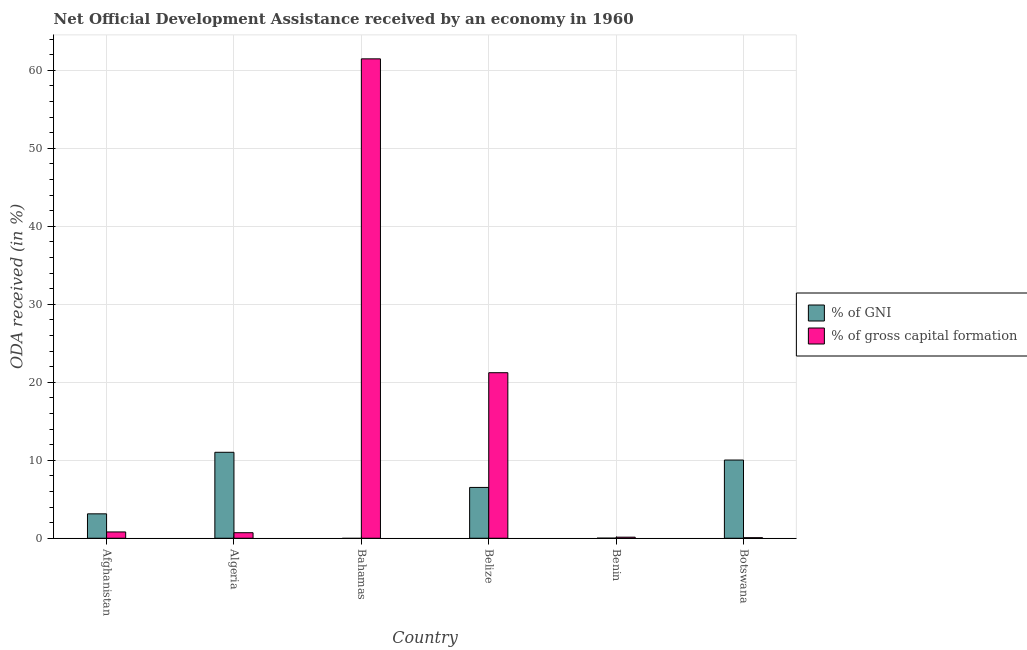How many different coloured bars are there?
Your answer should be compact. 2. Are the number of bars per tick equal to the number of legend labels?
Offer a very short reply. No. Are the number of bars on each tick of the X-axis equal?
Keep it short and to the point. No. How many bars are there on the 1st tick from the right?
Your answer should be very brief. 2. What is the label of the 6th group of bars from the left?
Provide a succinct answer. Botswana. What is the oda received as percentage of gni in Bahamas?
Your answer should be compact. 0. Across all countries, what is the maximum oda received as percentage of gni?
Give a very brief answer. 11.02. Across all countries, what is the minimum oda received as percentage of gross capital formation?
Provide a short and direct response. 0.07. In which country was the oda received as percentage of gni maximum?
Offer a terse response. Algeria. What is the total oda received as percentage of gross capital formation in the graph?
Keep it short and to the point. 84.42. What is the difference between the oda received as percentage of gross capital formation in Belize and that in Botswana?
Provide a succinct answer. 21.16. What is the difference between the oda received as percentage of gni in Bahamas and the oda received as percentage of gross capital formation in Belize?
Your response must be concise. -21.23. What is the average oda received as percentage of gni per country?
Give a very brief answer. 5.12. What is the difference between the oda received as percentage of gross capital formation and oda received as percentage of gni in Afghanistan?
Your answer should be compact. -2.32. In how many countries, is the oda received as percentage of gross capital formation greater than 36 %?
Ensure brevity in your answer.  1. What is the ratio of the oda received as percentage of gross capital formation in Algeria to that in Bahamas?
Make the answer very short. 0.01. What is the difference between the highest and the second highest oda received as percentage of gross capital formation?
Provide a succinct answer. 40.24. What is the difference between the highest and the lowest oda received as percentage of gross capital formation?
Provide a short and direct response. 61.4. In how many countries, is the oda received as percentage of gni greater than the average oda received as percentage of gni taken over all countries?
Provide a short and direct response. 3. Is the sum of the oda received as percentage of gross capital formation in Algeria and Bahamas greater than the maximum oda received as percentage of gni across all countries?
Keep it short and to the point. Yes. How many bars are there?
Provide a succinct answer. 11. Are all the bars in the graph horizontal?
Ensure brevity in your answer.  No. How many countries are there in the graph?
Give a very brief answer. 6. Does the graph contain grids?
Give a very brief answer. Yes. How are the legend labels stacked?
Provide a succinct answer. Vertical. What is the title of the graph?
Provide a succinct answer. Net Official Development Assistance received by an economy in 1960. What is the label or title of the Y-axis?
Offer a terse response. ODA received (in %). What is the ODA received (in %) in % of GNI in Afghanistan?
Your response must be concise. 3.13. What is the ODA received (in %) in % of gross capital formation in Afghanistan?
Keep it short and to the point. 0.81. What is the ODA received (in %) in % of GNI in Algeria?
Provide a succinct answer. 11.02. What is the ODA received (in %) of % of gross capital formation in Algeria?
Keep it short and to the point. 0.71. What is the ODA received (in %) of % of gross capital formation in Bahamas?
Give a very brief answer. 61.47. What is the ODA received (in %) in % of GNI in Belize?
Your response must be concise. 6.52. What is the ODA received (in %) in % of gross capital formation in Belize?
Offer a terse response. 21.23. What is the ODA received (in %) of % of GNI in Benin?
Your answer should be very brief. 0.01. What is the ODA received (in %) of % of gross capital formation in Benin?
Make the answer very short. 0.14. What is the ODA received (in %) in % of GNI in Botswana?
Ensure brevity in your answer.  10.03. What is the ODA received (in %) of % of gross capital formation in Botswana?
Provide a short and direct response. 0.07. Across all countries, what is the maximum ODA received (in %) in % of GNI?
Make the answer very short. 11.02. Across all countries, what is the maximum ODA received (in %) in % of gross capital formation?
Ensure brevity in your answer.  61.47. Across all countries, what is the minimum ODA received (in %) of % of gross capital formation?
Ensure brevity in your answer.  0.07. What is the total ODA received (in %) in % of GNI in the graph?
Your answer should be very brief. 30.7. What is the total ODA received (in %) of % of gross capital formation in the graph?
Give a very brief answer. 84.42. What is the difference between the ODA received (in %) of % of GNI in Afghanistan and that in Algeria?
Keep it short and to the point. -7.89. What is the difference between the ODA received (in %) of % of gross capital formation in Afghanistan and that in Algeria?
Offer a terse response. 0.1. What is the difference between the ODA received (in %) in % of gross capital formation in Afghanistan and that in Bahamas?
Keep it short and to the point. -60.66. What is the difference between the ODA received (in %) in % of GNI in Afghanistan and that in Belize?
Make the answer very short. -3.39. What is the difference between the ODA received (in %) of % of gross capital formation in Afghanistan and that in Belize?
Offer a very short reply. -20.42. What is the difference between the ODA received (in %) in % of GNI in Afghanistan and that in Benin?
Your response must be concise. 3.12. What is the difference between the ODA received (in %) in % of gross capital formation in Afghanistan and that in Benin?
Keep it short and to the point. 0.67. What is the difference between the ODA received (in %) in % of GNI in Afghanistan and that in Botswana?
Your response must be concise. -6.9. What is the difference between the ODA received (in %) of % of gross capital formation in Afghanistan and that in Botswana?
Make the answer very short. 0.74. What is the difference between the ODA received (in %) of % of gross capital formation in Algeria and that in Bahamas?
Your answer should be compact. -60.76. What is the difference between the ODA received (in %) of % of GNI in Algeria and that in Belize?
Your answer should be compact. 4.51. What is the difference between the ODA received (in %) in % of gross capital formation in Algeria and that in Belize?
Your answer should be very brief. -20.52. What is the difference between the ODA received (in %) of % of GNI in Algeria and that in Benin?
Keep it short and to the point. 11.01. What is the difference between the ODA received (in %) in % of gross capital formation in Algeria and that in Benin?
Your answer should be compact. 0.57. What is the difference between the ODA received (in %) in % of GNI in Algeria and that in Botswana?
Your answer should be compact. 0.99. What is the difference between the ODA received (in %) in % of gross capital formation in Algeria and that in Botswana?
Offer a very short reply. 0.64. What is the difference between the ODA received (in %) in % of gross capital formation in Bahamas and that in Belize?
Your answer should be very brief. 40.24. What is the difference between the ODA received (in %) in % of gross capital formation in Bahamas and that in Benin?
Make the answer very short. 61.33. What is the difference between the ODA received (in %) in % of gross capital formation in Bahamas and that in Botswana?
Make the answer very short. 61.4. What is the difference between the ODA received (in %) of % of GNI in Belize and that in Benin?
Keep it short and to the point. 6.51. What is the difference between the ODA received (in %) of % of gross capital formation in Belize and that in Benin?
Offer a very short reply. 21.09. What is the difference between the ODA received (in %) in % of GNI in Belize and that in Botswana?
Provide a succinct answer. -3.51. What is the difference between the ODA received (in %) of % of gross capital formation in Belize and that in Botswana?
Keep it short and to the point. 21.16. What is the difference between the ODA received (in %) of % of GNI in Benin and that in Botswana?
Your answer should be very brief. -10.02. What is the difference between the ODA received (in %) in % of gross capital formation in Benin and that in Botswana?
Ensure brevity in your answer.  0.07. What is the difference between the ODA received (in %) of % of GNI in Afghanistan and the ODA received (in %) of % of gross capital formation in Algeria?
Make the answer very short. 2.42. What is the difference between the ODA received (in %) of % of GNI in Afghanistan and the ODA received (in %) of % of gross capital formation in Bahamas?
Offer a very short reply. -58.34. What is the difference between the ODA received (in %) of % of GNI in Afghanistan and the ODA received (in %) of % of gross capital formation in Belize?
Provide a short and direct response. -18.1. What is the difference between the ODA received (in %) in % of GNI in Afghanistan and the ODA received (in %) in % of gross capital formation in Benin?
Ensure brevity in your answer.  2.99. What is the difference between the ODA received (in %) in % of GNI in Afghanistan and the ODA received (in %) in % of gross capital formation in Botswana?
Offer a terse response. 3.06. What is the difference between the ODA received (in %) of % of GNI in Algeria and the ODA received (in %) of % of gross capital formation in Bahamas?
Your answer should be compact. -50.45. What is the difference between the ODA received (in %) of % of GNI in Algeria and the ODA received (in %) of % of gross capital formation in Belize?
Offer a terse response. -10.2. What is the difference between the ODA received (in %) of % of GNI in Algeria and the ODA received (in %) of % of gross capital formation in Benin?
Keep it short and to the point. 10.88. What is the difference between the ODA received (in %) in % of GNI in Algeria and the ODA received (in %) in % of gross capital formation in Botswana?
Keep it short and to the point. 10.95. What is the difference between the ODA received (in %) in % of GNI in Belize and the ODA received (in %) in % of gross capital formation in Benin?
Make the answer very short. 6.38. What is the difference between the ODA received (in %) in % of GNI in Belize and the ODA received (in %) in % of gross capital formation in Botswana?
Make the answer very short. 6.45. What is the difference between the ODA received (in %) of % of GNI in Benin and the ODA received (in %) of % of gross capital formation in Botswana?
Your answer should be very brief. -0.06. What is the average ODA received (in %) in % of GNI per country?
Give a very brief answer. 5.12. What is the average ODA received (in %) in % of gross capital formation per country?
Keep it short and to the point. 14.07. What is the difference between the ODA received (in %) of % of GNI and ODA received (in %) of % of gross capital formation in Afghanistan?
Offer a very short reply. 2.32. What is the difference between the ODA received (in %) of % of GNI and ODA received (in %) of % of gross capital formation in Algeria?
Your response must be concise. 10.31. What is the difference between the ODA received (in %) in % of GNI and ODA received (in %) in % of gross capital formation in Belize?
Keep it short and to the point. -14.71. What is the difference between the ODA received (in %) of % of GNI and ODA received (in %) of % of gross capital formation in Benin?
Give a very brief answer. -0.13. What is the difference between the ODA received (in %) of % of GNI and ODA received (in %) of % of gross capital formation in Botswana?
Ensure brevity in your answer.  9.96. What is the ratio of the ODA received (in %) of % of GNI in Afghanistan to that in Algeria?
Ensure brevity in your answer.  0.28. What is the ratio of the ODA received (in %) of % of gross capital formation in Afghanistan to that in Algeria?
Your response must be concise. 1.14. What is the ratio of the ODA received (in %) of % of gross capital formation in Afghanistan to that in Bahamas?
Your answer should be compact. 0.01. What is the ratio of the ODA received (in %) of % of GNI in Afghanistan to that in Belize?
Offer a very short reply. 0.48. What is the ratio of the ODA received (in %) in % of gross capital formation in Afghanistan to that in Belize?
Your answer should be very brief. 0.04. What is the ratio of the ODA received (in %) in % of GNI in Afghanistan to that in Benin?
Ensure brevity in your answer.  352.88. What is the ratio of the ODA received (in %) of % of gross capital formation in Afghanistan to that in Benin?
Give a very brief answer. 5.93. What is the ratio of the ODA received (in %) of % of GNI in Afghanistan to that in Botswana?
Make the answer very short. 0.31. What is the ratio of the ODA received (in %) of % of gross capital formation in Afghanistan to that in Botswana?
Keep it short and to the point. 11.46. What is the ratio of the ODA received (in %) of % of gross capital formation in Algeria to that in Bahamas?
Your response must be concise. 0.01. What is the ratio of the ODA received (in %) in % of GNI in Algeria to that in Belize?
Your response must be concise. 1.69. What is the ratio of the ODA received (in %) in % of gross capital formation in Algeria to that in Belize?
Make the answer very short. 0.03. What is the ratio of the ODA received (in %) in % of GNI in Algeria to that in Benin?
Provide a succinct answer. 1242.53. What is the ratio of the ODA received (in %) of % of gross capital formation in Algeria to that in Benin?
Give a very brief answer. 5.21. What is the ratio of the ODA received (in %) in % of GNI in Algeria to that in Botswana?
Your response must be concise. 1.1. What is the ratio of the ODA received (in %) of % of gross capital formation in Algeria to that in Botswana?
Ensure brevity in your answer.  10.08. What is the ratio of the ODA received (in %) of % of gross capital formation in Bahamas to that in Belize?
Your answer should be very brief. 2.9. What is the ratio of the ODA received (in %) of % of gross capital formation in Bahamas to that in Benin?
Make the answer very short. 451.25. What is the ratio of the ODA received (in %) in % of gross capital formation in Bahamas to that in Botswana?
Ensure brevity in your answer.  872.14. What is the ratio of the ODA received (in %) in % of GNI in Belize to that in Benin?
Provide a short and direct response. 734.62. What is the ratio of the ODA received (in %) of % of gross capital formation in Belize to that in Benin?
Offer a very short reply. 155.82. What is the ratio of the ODA received (in %) in % of GNI in Belize to that in Botswana?
Give a very brief answer. 0.65. What is the ratio of the ODA received (in %) of % of gross capital formation in Belize to that in Botswana?
Offer a terse response. 301.15. What is the ratio of the ODA received (in %) in % of GNI in Benin to that in Botswana?
Provide a succinct answer. 0. What is the ratio of the ODA received (in %) in % of gross capital formation in Benin to that in Botswana?
Provide a short and direct response. 1.93. What is the difference between the highest and the second highest ODA received (in %) of % of gross capital formation?
Keep it short and to the point. 40.24. What is the difference between the highest and the lowest ODA received (in %) of % of GNI?
Provide a short and direct response. 11.02. What is the difference between the highest and the lowest ODA received (in %) in % of gross capital formation?
Keep it short and to the point. 61.4. 